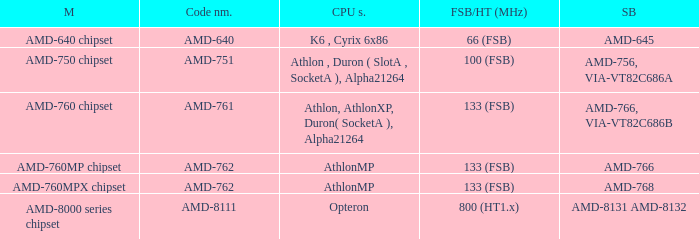What is the Southbridge when the CPU support was athlon, athlonxp, duron( socketa ), alpha21264? AMD-766, VIA-VT82C686B. 